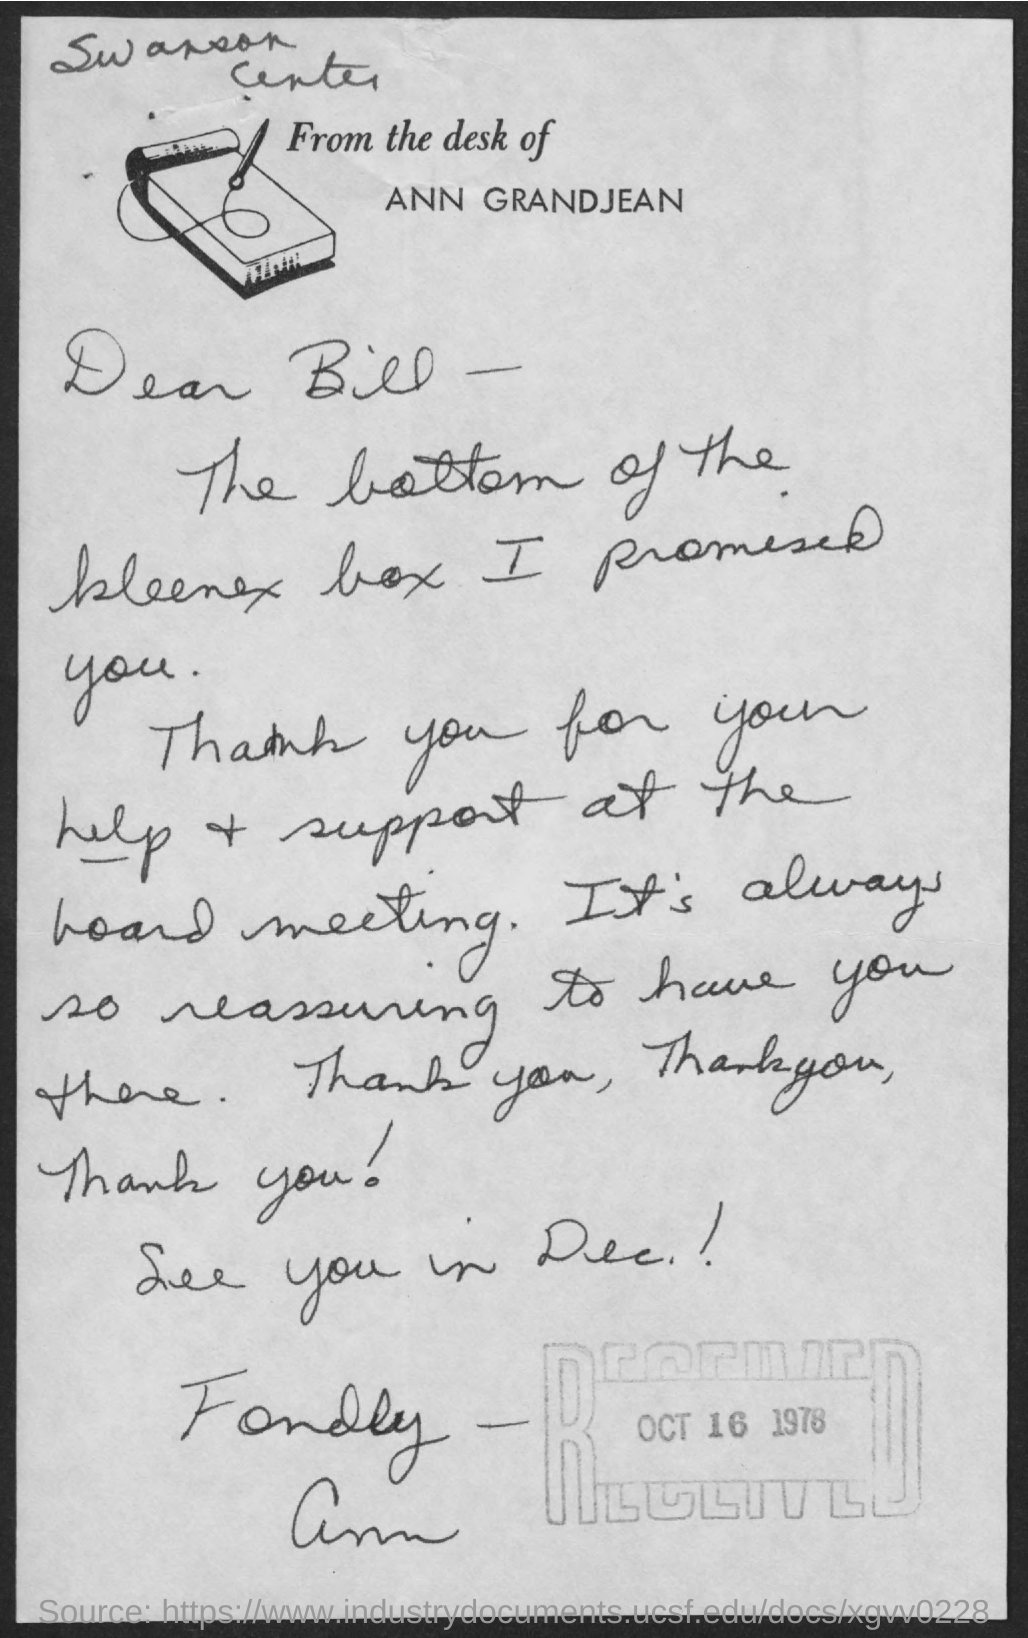Mention a couple of crucial points in this snapshot. The letter is addressed to Bill. The sender of this letter is ANN GRANDJEAN. 